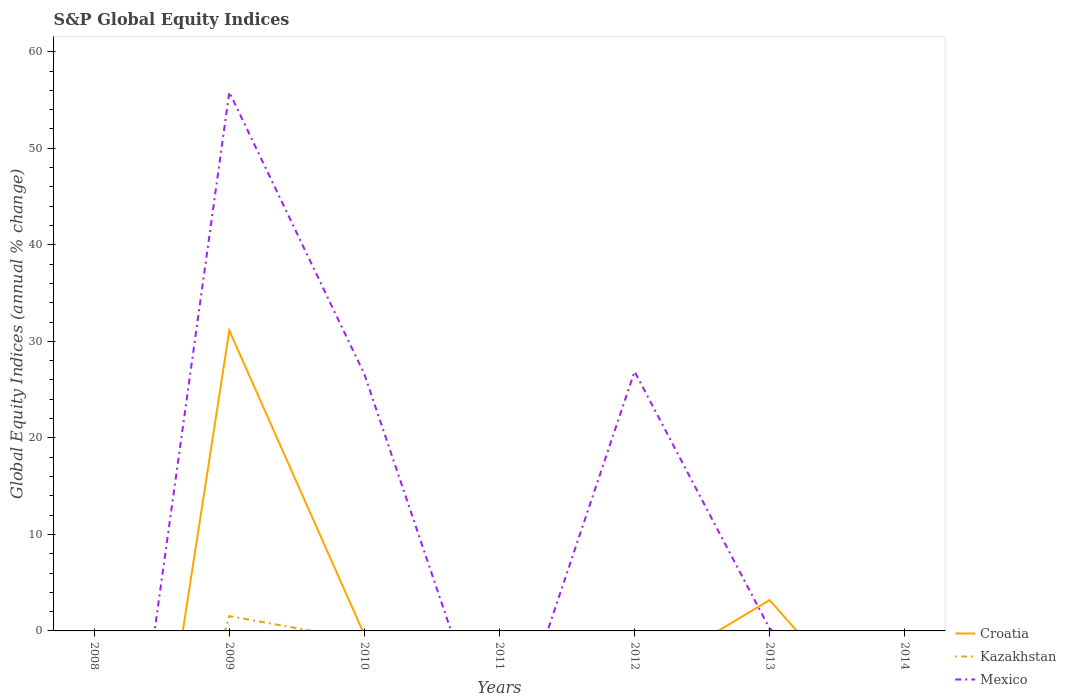Does the line corresponding to Mexico intersect with the line corresponding to Kazakhstan?
Provide a short and direct response. No. Is the number of lines equal to the number of legend labels?
Make the answer very short. No. Across all years, what is the maximum global equity indices in Mexico?
Keep it short and to the point. 0. What is the difference between the highest and the second highest global equity indices in Mexico?
Ensure brevity in your answer.  55.81. How many years are there in the graph?
Your response must be concise. 7. What is the difference between two consecutive major ticks on the Y-axis?
Offer a very short reply. 10. Does the graph contain any zero values?
Make the answer very short. Yes. Where does the legend appear in the graph?
Your answer should be very brief. Bottom right. What is the title of the graph?
Offer a terse response. S&P Global Equity Indices. What is the label or title of the X-axis?
Offer a very short reply. Years. What is the label or title of the Y-axis?
Give a very brief answer. Global Equity Indices (annual % change). What is the Global Equity Indices (annual % change) in Croatia in 2008?
Provide a succinct answer. 0. What is the Global Equity Indices (annual % change) of Kazakhstan in 2008?
Your answer should be compact. 0. What is the Global Equity Indices (annual % change) in Croatia in 2009?
Your answer should be compact. 31.11. What is the Global Equity Indices (annual % change) in Kazakhstan in 2009?
Keep it short and to the point. 1.53. What is the Global Equity Indices (annual % change) of Mexico in 2009?
Give a very brief answer. 55.81. What is the Global Equity Indices (annual % change) of Mexico in 2010?
Keep it short and to the point. 26.6. What is the Global Equity Indices (annual % change) in Croatia in 2011?
Keep it short and to the point. 0. What is the Global Equity Indices (annual % change) of Kazakhstan in 2011?
Your response must be concise. 0. What is the Global Equity Indices (annual % change) in Mexico in 2011?
Offer a terse response. 0. What is the Global Equity Indices (annual % change) in Croatia in 2012?
Give a very brief answer. 0. What is the Global Equity Indices (annual % change) in Mexico in 2012?
Keep it short and to the point. 26.87. What is the Global Equity Indices (annual % change) in Croatia in 2013?
Give a very brief answer. 3.2. What is the Global Equity Indices (annual % change) in Mexico in 2013?
Provide a succinct answer. 0.24. What is the Global Equity Indices (annual % change) in Kazakhstan in 2014?
Provide a short and direct response. 0. Across all years, what is the maximum Global Equity Indices (annual % change) of Croatia?
Your answer should be compact. 31.11. Across all years, what is the maximum Global Equity Indices (annual % change) in Kazakhstan?
Make the answer very short. 1.53. Across all years, what is the maximum Global Equity Indices (annual % change) of Mexico?
Offer a very short reply. 55.81. Across all years, what is the minimum Global Equity Indices (annual % change) of Kazakhstan?
Your response must be concise. 0. What is the total Global Equity Indices (annual % change) in Croatia in the graph?
Your answer should be compact. 34.31. What is the total Global Equity Indices (annual % change) in Kazakhstan in the graph?
Offer a terse response. 1.53. What is the total Global Equity Indices (annual % change) in Mexico in the graph?
Make the answer very short. 109.52. What is the difference between the Global Equity Indices (annual % change) in Mexico in 2009 and that in 2010?
Your answer should be compact. 29.22. What is the difference between the Global Equity Indices (annual % change) of Mexico in 2009 and that in 2012?
Keep it short and to the point. 28.94. What is the difference between the Global Equity Indices (annual % change) of Croatia in 2009 and that in 2013?
Your answer should be compact. 27.92. What is the difference between the Global Equity Indices (annual % change) in Mexico in 2009 and that in 2013?
Offer a very short reply. 55.58. What is the difference between the Global Equity Indices (annual % change) in Mexico in 2010 and that in 2012?
Ensure brevity in your answer.  -0.28. What is the difference between the Global Equity Indices (annual % change) in Mexico in 2010 and that in 2013?
Give a very brief answer. 26.36. What is the difference between the Global Equity Indices (annual % change) of Mexico in 2012 and that in 2013?
Ensure brevity in your answer.  26.64. What is the difference between the Global Equity Indices (annual % change) in Croatia in 2009 and the Global Equity Indices (annual % change) in Mexico in 2010?
Give a very brief answer. 4.52. What is the difference between the Global Equity Indices (annual % change) in Kazakhstan in 2009 and the Global Equity Indices (annual % change) in Mexico in 2010?
Provide a short and direct response. -25.06. What is the difference between the Global Equity Indices (annual % change) in Croatia in 2009 and the Global Equity Indices (annual % change) in Mexico in 2012?
Offer a terse response. 4.24. What is the difference between the Global Equity Indices (annual % change) of Kazakhstan in 2009 and the Global Equity Indices (annual % change) of Mexico in 2012?
Your answer should be compact. -25.34. What is the difference between the Global Equity Indices (annual % change) of Croatia in 2009 and the Global Equity Indices (annual % change) of Mexico in 2013?
Ensure brevity in your answer.  30.88. What is the difference between the Global Equity Indices (annual % change) of Kazakhstan in 2009 and the Global Equity Indices (annual % change) of Mexico in 2013?
Provide a short and direct response. 1.29. What is the average Global Equity Indices (annual % change) in Croatia per year?
Keep it short and to the point. 4.9. What is the average Global Equity Indices (annual % change) in Kazakhstan per year?
Your response must be concise. 0.22. What is the average Global Equity Indices (annual % change) in Mexico per year?
Your answer should be very brief. 15.65. In the year 2009, what is the difference between the Global Equity Indices (annual % change) in Croatia and Global Equity Indices (annual % change) in Kazakhstan?
Provide a short and direct response. 29.58. In the year 2009, what is the difference between the Global Equity Indices (annual % change) of Croatia and Global Equity Indices (annual % change) of Mexico?
Keep it short and to the point. -24.7. In the year 2009, what is the difference between the Global Equity Indices (annual % change) of Kazakhstan and Global Equity Indices (annual % change) of Mexico?
Your answer should be compact. -54.28. In the year 2013, what is the difference between the Global Equity Indices (annual % change) in Croatia and Global Equity Indices (annual % change) in Mexico?
Your answer should be compact. 2.96. What is the ratio of the Global Equity Indices (annual % change) of Mexico in 2009 to that in 2010?
Give a very brief answer. 2.1. What is the ratio of the Global Equity Indices (annual % change) in Mexico in 2009 to that in 2012?
Your answer should be compact. 2.08. What is the ratio of the Global Equity Indices (annual % change) in Croatia in 2009 to that in 2013?
Provide a succinct answer. 9.73. What is the ratio of the Global Equity Indices (annual % change) in Mexico in 2009 to that in 2013?
Offer a very short reply. 235.13. What is the ratio of the Global Equity Indices (annual % change) of Mexico in 2010 to that in 2012?
Your answer should be very brief. 0.99. What is the ratio of the Global Equity Indices (annual % change) of Mexico in 2010 to that in 2013?
Your response must be concise. 112.04. What is the ratio of the Global Equity Indices (annual % change) of Mexico in 2012 to that in 2013?
Offer a terse response. 113.21. What is the difference between the highest and the second highest Global Equity Indices (annual % change) in Mexico?
Keep it short and to the point. 28.94. What is the difference between the highest and the lowest Global Equity Indices (annual % change) in Croatia?
Make the answer very short. 31.11. What is the difference between the highest and the lowest Global Equity Indices (annual % change) in Kazakhstan?
Make the answer very short. 1.53. What is the difference between the highest and the lowest Global Equity Indices (annual % change) of Mexico?
Your answer should be compact. 55.81. 